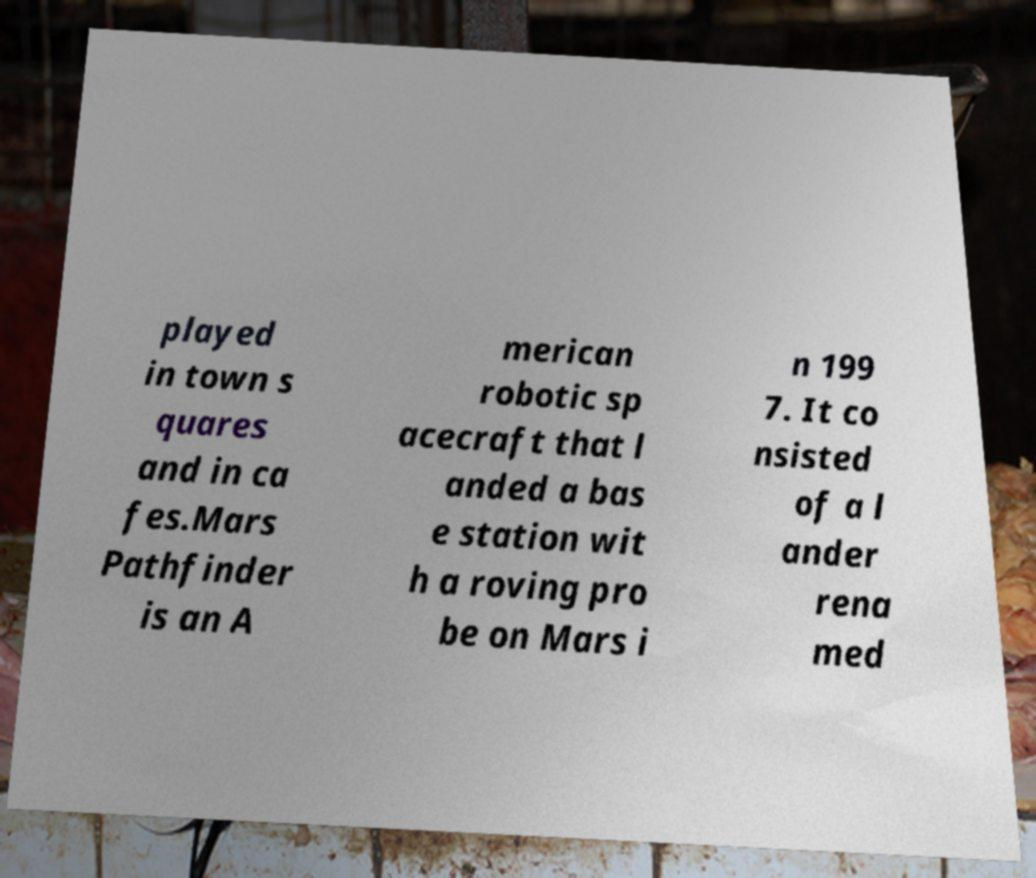I need the written content from this picture converted into text. Can you do that? played in town s quares and in ca fes.Mars Pathfinder is an A merican robotic sp acecraft that l anded a bas e station wit h a roving pro be on Mars i n 199 7. It co nsisted of a l ander rena med 